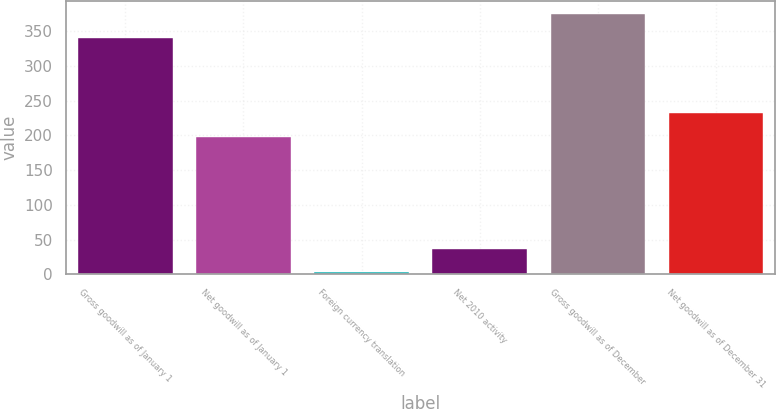Convert chart. <chart><loc_0><loc_0><loc_500><loc_500><bar_chart><fcel>Gross goodwill as of January 1<fcel>Net goodwill as of January 1<fcel>Foreign currency translation<fcel>Net 2010 activity<fcel>Gross goodwill as of December<fcel>Net goodwill as of December 31<nl><fcel>340.6<fcel>198<fcel>2.9<fcel>36.96<fcel>374.66<fcel>232.06<nl></chart> 